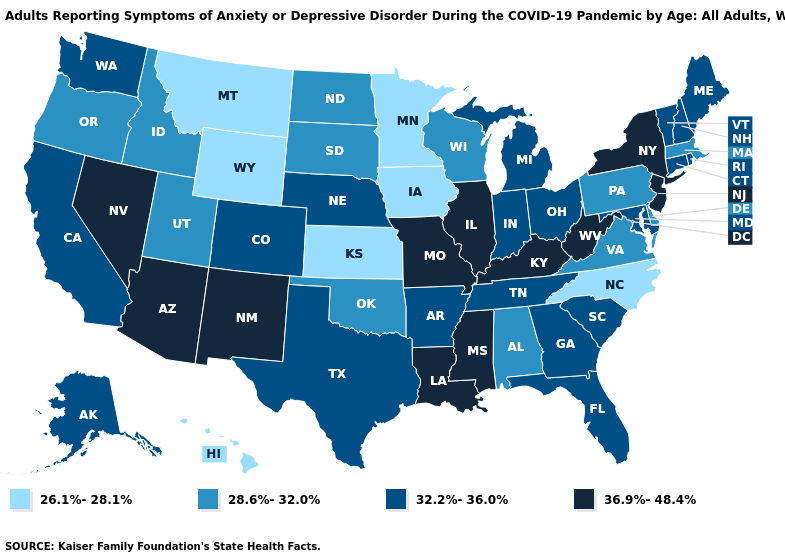Does the first symbol in the legend represent the smallest category?
Short answer required. Yes. Name the states that have a value in the range 36.9%-48.4%?
Give a very brief answer. Arizona, Illinois, Kentucky, Louisiana, Mississippi, Missouri, Nevada, New Jersey, New Mexico, New York, West Virginia. What is the highest value in states that border Wisconsin?
Keep it brief. 36.9%-48.4%. Among the states that border Arizona , does Utah have the lowest value?
Quick response, please. Yes. Which states have the lowest value in the USA?
Quick response, please. Hawaii, Iowa, Kansas, Minnesota, Montana, North Carolina, Wyoming. What is the value of Montana?
Concise answer only. 26.1%-28.1%. Among the states that border New Hampshire , which have the lowest value?
Answer briefly. Massachusetts. Among the states that border New Mexico , which have the highest value?
Give a very brief answer. Arizona. Name the states that have a value in the range 32.2%-36.0%?
Give a very brief answer. Alaska, Arkansas, California, Colorado, Connecticut, Florida, Georgia, Indiana, Maine, Maryland, Michigan, Nebraska, New Hampshire, Ohio, Rhode Island, South Carolina, Tennessee, Texas, Vermont, Washington. What is the highest value in the USA?
Short answer required. 36.9%-48.4%. What is the value of Indiana?
Answer briefly. 32.2%-36.0%. Does Maryland have a higher value than Louisiana?
Write a very short answer. No. What is the value of California?
Concise answer only. 32.2%-36.0%. Name the states that have a value in the range 32.2%-36.0%?
Be succinct. Alaska, Arkansas, California, Colorado, Connecticut, Florida, Georgia, Indiana, Maine, Maryland, Michigan, Nebraska, New Hampshire, Ohio, Rhode Island, South Carolina, Tennessee, Texas, Vermont, Washington. What is the highest value in the USA?
Be succinct. 36.9%-48.4%. 